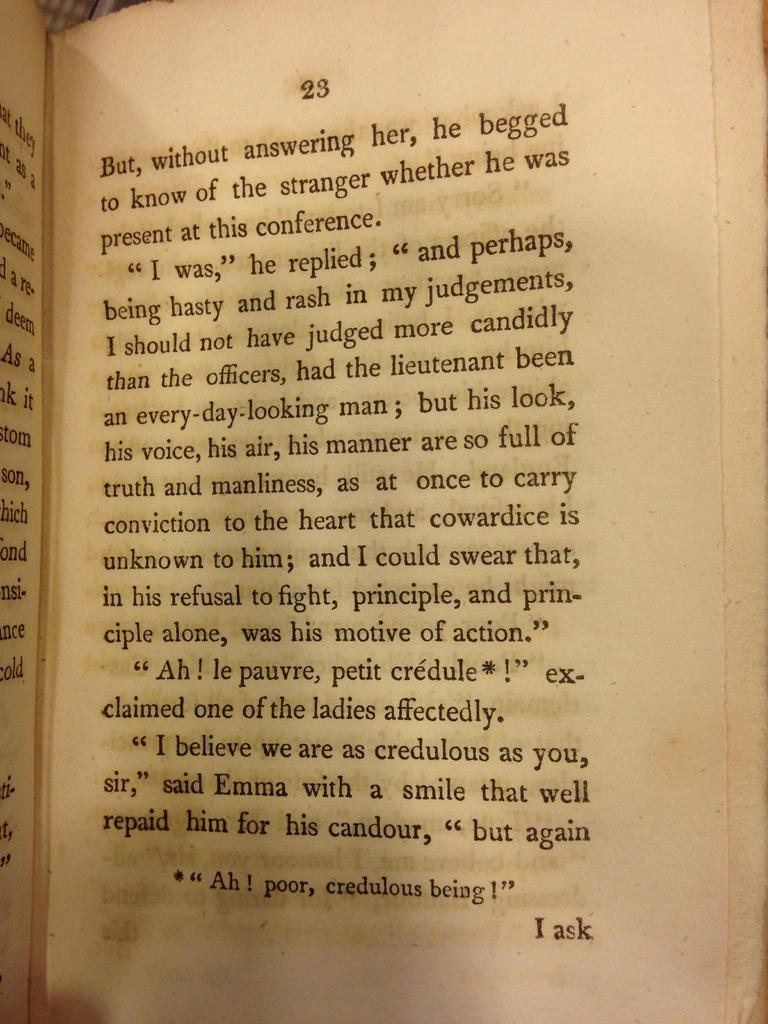<image>
Relay a brief, clear account of the picture shown. an open book page that is the number 23 